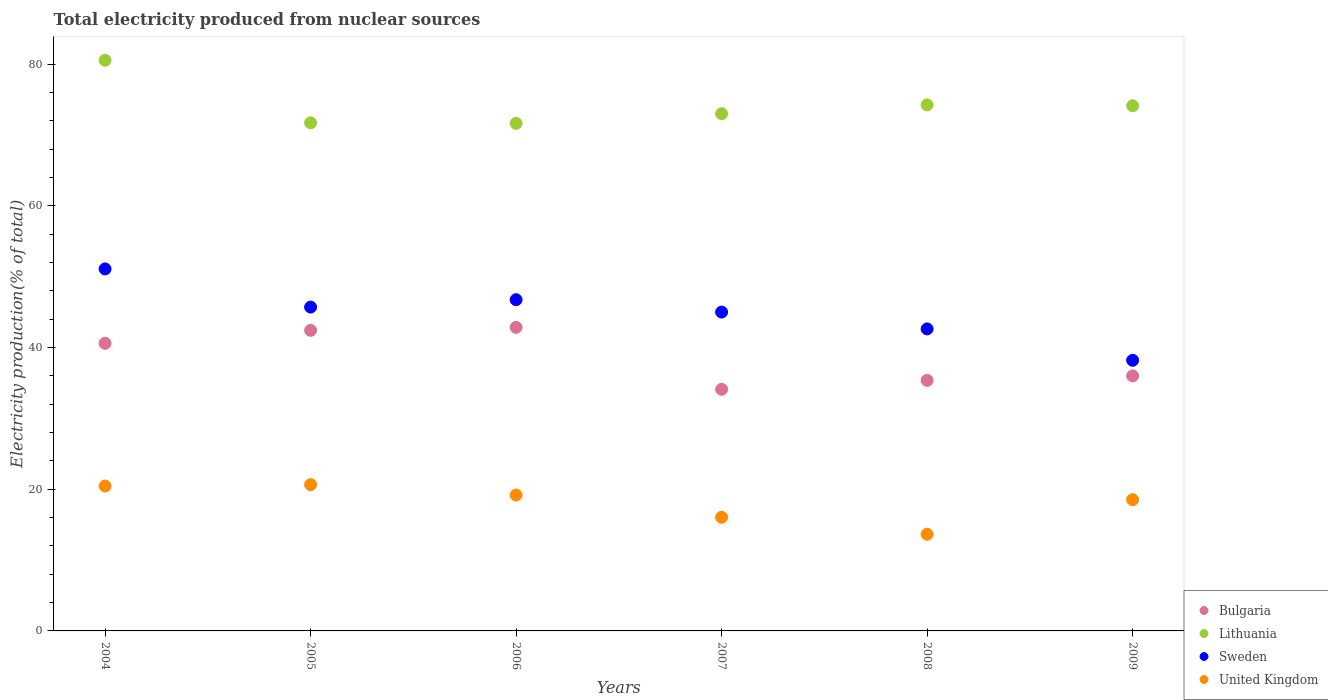How many different coloured dotlines are there?
Provide a short and direct response. 4. What is the total electricity produced in Sweden in 2004?
Give a very brief answer. 51.09. Across all years, what is the maximum total electricity produced in Sweden?
Ensure brevity in your answer.  51.09. Across all years, what is the minimum total electricity produced in United Kingdom?
Offer a very short reply. 13.64. What is the total total electricity produced in Bulgaria in the graph?
Offer a terse response. 231.31. What is the difference between the total electricity produced in Bulgaria in 2004 and that in 2006?
Keep it short and to the point. -2.25. What is the difference between the total electricity produced in United Kingdom in 2006 and the total electricity produced in Bulgaria in 2009?
Provide a short and direct response. -16.82. What is the average total electricity produced in Sweden per year?
Offer a very short reply. 44.89. In the year 2005, what is the difference between the total electricity produced in United Kingdom and total electricity produced in Sweden?
Offer a terse response. -25.06. What is the ratio of the total electricity produced in Lithuania in 2004 to that in 2008?
Your answer should be very brief. 1.08. What is the difference between the highest and the second highest total electricity produced in Lithuania?
Provide a short and direct response. 6.3. What is the difference between the highest and the lowest total electricity produced in Lithuania?
Keep it short and to the point. 8.9. In how many years, is the total electricity produced in Lithuania greater than the average total electricity produced in Lithuania taken over all years?
Your answer should be very brief. 2. Is it the case that in every year, the sum of the total electricity produced in Sweden and total electricity produced in Lithuania  is greater than the total electricity produced in United Kingdom?
Your answer should be compact. Yes. Does the total electricity produced in United Kingdom monotonically increase over the years?
Make the answer very short. No. Is the total electricity produced in Lithuania strictly less than the total electricity produced in Bulgaria over the years?
Make the answer very short. No. What is the difference between two consecutive major ticks on the Y-axis?
Provide a succinct answer. 20. Does the graph contain grids?
Keep it short and to the point. No. How are the legend labels stacked?
Ensure brevity in your answer.  Vertical. What is the title of the graph?
Offer a very short reply. Total electricity produced from nuclear sources. What is the label or title of the X-axis?
Your answer should be compact. Years. What is the label or title of the Y-axis?
Your response must be concise. Electricity production(% of total). What is the Electricity production(% of total) in Bulgaria in 2004?
Keep it short and to the point. 40.59. What is the Electricity production(% of total) of Lithuania in 2004?
Give a very brief answer. 80.54. What is the Electricity production(% of total) in Sweden in 2004?
Keep it short and to the point. 51.09. What is the Electricity production(% of total) of United Kingdom in 2004?
Offer a very short reply. 20.45. What is the Electricity production(% of total) of Bulgaria in 2005?
Give a very brief answer. 42.42. What is the Electricity production(% of total) of Lithuania in 2005?
Your response must be concise. 71.71. What is the Electricity production(% of total) of Sweden in 2005?
Your answer should be compact. 45.7. What is the Electricity production(% of total) of United Kingdom in 2005?
Offer a terse response. 20.64. What is the Electricity production(% of total) in Bulgaria in 2006?
Give a very brief answer. 42.84. What is the Electricity production(% of total) in Lithuania in 2006?
Offer a very short reply. 71.63. What is the Electricity production(% of total) in Sweden in 2006?
Provide a succinct answer. 46.74. What is the Electricity production(% of total) of United Kingdom in 2006?
Offer a very short reply. 19.18. What is the Electricity production(% of total) of Bulgaria in 2007?
Give a very brief answer. 34.1. What is the Electricity production(% of total) of Lithuania in 2007?
Ensure brevity in your answer.  73. What is the Electricity production(% of total) of Sweden in 2007?
Offer a very short reply. 45. What is the Electricity production(% of total) in United Kingdom in 2007?
Keep it short and to the point. 16.04. What is the Electricity production(% of total) of Bulgaria in 2008?
Offer a terse response. 35.36. What is the Electricity production(% of total) in Lithuania in 2008?
Offer a terse response. 74.24. What is the Electricity production(% of total) of Sweden in 2008?
Make the answer very short. 42.62. What is the Electricity production(% of total) of United Kingdom in 2008?
Give a very brief answer. 13.64. What is the Electricity production(% of total) in Bulgaria in 2009?
Ensure brevity in your answer.  36. What is the Electricity production(% of total) of Lithuania in 2009?
Give a very brief answer. 74.11. What is the Electricity production(% of total) in Sweden in 2009?
Ensure brevity in your answer.  38.19. What is the Electricity production(% of total) of United Kingdom in 2009?
Make the answer very short. 18.52. Across all years, what is the maximum Electricity production(% of total) of Bulgaria?
Your response must be concise. 42.84. Across all years, what is the maximum Electricity production(% of total) of Lithuania?
Offer a terse response. 80.54. Across all years, what is the maximum Electricity production(% of total) in Sweden?
Give a very brief answer. 51.09. Across all years, what is the maximum Electricity production(% of total) of United Kingdom?
Provide a succinct answer. 20.64. Across all years, what is the minimum Electricity production(% of total) in Bulgaria?
Make the answer very short. 34.1. Across all years, what is the minimum Electricity production(% of total) in Lithuania?
Keep it short and to the point. 71.63. Across all years, what is the minimum Electricity production(% of total) of Sweden?
Offer a very short reply. 38.19. Across all years, what is the minimum Electricity production(% of total) in United Kingdom?
Your answer should be very brief. 13.64. What is the total Electricity production(% of total) in Bulgaria in the graph?
Your answer should be very brief. 231.31. What is the total Electricity production(% of total) of Lithuania in the graph?
Keep it short and to the point. 445.23. What is the total Electricity production(% of total) of Sweden in the graph?
Offer a terse response. 269.35. What is the total Electricity production(% of total) in United Kingdom in the graph?
Make the answer very short. 108.46. What is the difference between the Electricity production(% of total) of Bulgaria in 2004 and that in 2005?
Offer a very short reply. -1.83. What is the difference between the Electricity production(% of total) in Lithuania in 2004 and that in 2005?
Ensure brevity in your answer.  8.83. What is the difference between the Electricity production(% of total) in Sweden in 2004 and that in 2005?
Your answer should be compact. 5.38. What is the difference between the Electricity production(% of total) of United Kingdom in 2004 and that in 2005?
Keep it short and to the point. -0.2. What is the difference between the Electricity production(% of total) of Bulgaria in 2004 and that in 2006?
Provide a short and direct response. -2.25. What is the difference between the Electricity production(% of total) of Lithuania in 2004 and that in 2006?
Provide a short and direct response. 8.9. What is the difference between the Electricity production(% of total) of Sweden in 2004 and that in 2006?
Keep it short and to the point. 4.34. What is the difference between the Electricity production(% of total) of United Kingdom in 2004 and that in 2006?
Provide a succinct answer. 1.27. What is the difference between the Electricity production(% of total) in Bulgaria in 2004 and that in 2007?
Ensure brevity in your answer.  6.49. What is the difference between the Electricity production(% of total) in Lithuania in 2004 and that in 2007?
Provide a succinct answer. 7.54. What is the difference between the Electricity production(% of total) in Sweden in 2004 and that in 2007?
Provide a succinct answer. 6.09. What is the difference between the Electricity production(% of total) in United Kingdom in 2004 and that in 2007?
Give a very brief answer. 4.41. What is the difference between the Electricity production(% of total) of Bulgaria in 2004 and that in 2008?
Keep it short and to the point. 5.23. What is the difference between the Electricity production(% of total) in Lithuania in 2004 and that in 2008?
Your response must be concise. 6.3. What is the difference between the Electricity production(% of total) in Sweden in 2004 and that in 2008?
Give a very brief answer. 8.46. What is the difference between the Electricity production(% of total) of United Kingdom in 2004 and that in 2008?
Your answer should be very brief. 6.8. What is the difference between the Electricity production(% of total) in Bulgaria in 2004 and that in 2009?
Your answer should be compact. 4.59. What is the difference between the Electricity production(% of total) of Lithuania in 2004 and that in 2009?
Give a very brief answer. 6.42. What is the difference between the Electricity production(% of total) in Sweden in 2004 and that in 2009?
Your answer should be very brief. 12.89. What is the difference between the Electricity production(% of total) of United Kingdom in 2004 and that in 2009?
Provide a short and direct response. 1.92. What is the difference between the Electricity production(% of total) of Bulgaria in 2005 and that in 2006?
Make the answer very short. -0.42. What is the difference between the Electricity production(% of total) of Lithuania in 2005 and that in 2006?
Your response must be concise. 0.08. What is the difference between the Electricity production(% of total) in Sweden in 2005 and that in 2006?
Your answer should be very brief. -1.04. What is the difference between the Electricity production(% of total) in United Kingdom in 2005 and that in 2006?
Your answer should be compact. 1.46. What is the difference between the Electricity production(% of total) of Bulgaria in 2005 and that in 2007?
Ensure brevity in your answer.  8.32. What is the difference between the Electricity production(% of total) in Lithuania in 2005 and that in 2007?
Your answer should be very brief. -1.29. What is the difference between the Electricity production(% of total) in Sweden in 2005 and that in 2007?
Provide a succinct answer. 0.7. What is the difference between the Electricity production(% of total) of United Kingdom in 2005 and that in 2007?
Keep it short and to the point. 4.6. What is the difference between the Electricity production(% of total) of Bulgaria in 2005 and that in 2008?
Your answer should be very brief. 7.06. What is the difference between the Electricity production(% of total) in Lithuania in 2005 and that in 2008?
Provide a succinct answer. -2.53. What is the difference between the Electricity production(% of total) of Sweden in 2005 and that in 2008?
Provide a short and direct response. 3.08. What is the difference between the Electricity production(% of total) in United Kingdom in 2005 and that in 2008?
Ensure brevity in your answer.  7. What is the difference between the Electricity production(% of total) in Bulgaria in 2005 and that in 2009?
Provide a short and direct response. 6.42. What is the difference between the Electricity production(% of total) in Lithuania in 2005 and that in 2009?
Ensure brevity in your answer.  -2.4. What is the difference between the Electricity production(% of total) of Sweden in 2005 and that in 2009?
Give a very brief answer. 7.51. What is the difference between the Electricity production(% of total) in United Kingdom in 2005 and that in 2009?
Provide a short and direct response. 2.12. What is the difference between the Electricity production(% of total) in Bulgaria in 2006 and that in 2007?
Provide a short and direct response. 8.74. What is the difference between the Electricity production(% of total) of Lithuania in 2006 and that in 2007?
Provide a succinct answer. -1.37. What is the difference between the Electricity production(% of total) in Sweden in 2006 and that in 2007?
Provide a short and direct response. 1.74. What is the difference between the Electricity production(% of total) of United Kingdom in 2006 and that in 2007?
Your answer should be very brief. 3.14. What is the difference between the Electricity production(% of total) in Bulgaria in 2006 and that in 2008?
Your response must be concise. 7.48. What is the difference between the Electricity production(% of total) of Lithuania in 2006 and that in 2008?
Make the answer very short. -2.61. What is the difference between the Electricity production(% of total) of Sweden in 2006 and that in 2008?
Keep it short and to the point. 4.12. What is the difference between the Electricity production(% of total) in United Kingdom in 2006 and that in 2008?
Keep it short and to the point. 5.54. What is the difference between the Electricity production(% of total) in Bulgaria in 2006 and that in 2009?
Provide a succinct answer. 6.84. What is the difference between the Electricity production(% of total) in Lithuania in 2006 and that in 2009?
Keep it short and to the point. -2.48. What is the difference between the Electricity production(% of total) of Sweden in 2006 and that in 2009?
Make the answer very short. 8.55. What is the difference between the Electricity production(% of total) of United Kingdom in 2006 and that in 2009?
Your response must be concise. 0.66. What is the difference between the Electricity production(% of total) of Bulgaria in 2007 and that in 2008?
Ensure brevity in your answer.  -1.26. What is the difference between the Electricity production(% of total) in Lithuania in 2007 and that in 2008?
Your answer should be very brief. -1.24. What is the difference between the Electricity production(% of total) in Sweden in 2007 and that in 2008?
Your response must be concise. 2.38. What is the difference between the Electricity production(% of total) of United Kingdom in 2007 and that in 2008?
Keep it short and to the point. 2.4. What is the difference between the Electricity production(% of total) of Bulgaria in 2007 and that in 2009?
Your response must be concise. -1.89. What is the difference between the Electricity production(% of total) of Lithuania in 2007 and that in 2009?
Give a very brief answer. -1.11. What is the difference between the Electricity production(% of total) in Sweden in 2007 and that in 2009?
Ensure brevity in your answer.  6.81. What is the difference between the Electricity production(% of total) in United Kingdom in 2007 and that in 2009?
Offer a very short reply. -2.48. What is the difference between the Electricity production(% of total) in Bulgaria in 2008 and that in 2009?
Ensure brevity in your answer.  -0.64. What is the difference between the Electricity production(% of total) in Lithuania in 2008 and that in 2009?
Provide a short and direct response. 0.13. What is the difference between the Electricity production(% of total) of Sweden in 2008 and that in 2009?
Keep it short and to the point. 4.43. What is the difference between the Electricity production(% of total) in United Kingdom in 2008 and that in 2009?
Provide a succinct answer. -4.88. What is the difference between the Electricity production(% of total) in Bulgaria in 2004 and the Electricity production(% of total) in Lithuania in 2005?
Provide a short and direct response. -31.12. What is the difference between the Electricity production(% of total) in Bulgaria in 2004 and the Electricity production(% of total) in Sweden in 2005?
Your answer should be very brief. -5.11. What is the difference between the Electricity production(% of total) of Bulgaria in 2004 and the Electricity production(% of total) of United Kingdom in 2005?
Your response must be concise. 19.95. What is the difference between the Electricity production(% of total) of Lithuania in 2004 and the Electricity production(% of total) of Sweden in 2005?
Offer a terse response. 34.83. What is the difference between the Electricity production(% of total) of Lithuania in 2004 and the Electricity production(% of total) of United Kingdom in 2005?
Offer a very short reply. 59.89. What is the difference between the Electricity production(% of total) of Sweden in 2004 and the Electricity production(% of total) of United Kingdom in 2005?
Ensure brevity in your answer.  30.45. What is the difference between the Electricity production(% of total) in Bulgaria in 2004 and the Electricity production(% of total) in Lithuania in 2006?
Keep it short and to the point. -31.04. What is the difference between the Electricity production(% of total) of Bulgaria in 2004 and the Electricity production(% of total) of Sweden in 2006?
Provide a short and direct response. -6.15. What is the difference between the Electricity production(% of total) in Bulgaria in 2004 and the Electricity production(% of total) in United Kingdom in 2006?
Your response must be concise. 21.41. What is the difference between the Electricity production(% of total) in Lithuania in 2004 and the Electricity production(% of total) in Sweden in 2006?
Ensure brevity in your answer.  33.79. What is the difference between the Electricity production(% of total) of Lithuania in 2004 and the Electricity production(% of total) of United Kingdom in 2006?
Your answer should be very brief. 61.36. What is the difference between the Electricity production(% of total) in Sweden in 2004 and the Electricity production(% of total) in United Kingdom in 2006?
Give a very brief answer. 31.91. What is the difference between the Electricity production(% of total) in Bulgaria in 2004 and the Electricity production(% of total) in Lithuania in 2007?
Provide a short and direct response. -32.41. What is the difference between the Electricity production(% of total) in Bulgaria in 2004 and the Electricity production(% of total) in Sweden in 2007?
Your answer should be compact. -4.41. What is the difference between the Electricity production(% of total) in Bulgaria in 2004 and the Electricity production(% of total) in United Kingdom in 2007?
Provide a short and direct response. 24.55. What is the difference between the Electricity production(% of total) in Lithuania in 2004 and the Electricity production(% of total) in Sweden in 2007?
Offer a very short reply. 35.54. What is the difference between the Electricity production(% of total) in Lithuania in 2004 and the Electricity production(% of total) in United Kingdom in 2007?
Offer a very short reply. 64.5. What is the difference between the Electricity production(% of total) in Sweden in 2004 and the Electricity production(% of total) in United Kingdom in 2007?
Keep it short and to the point. 35.05. What is the difference between the Electricity production(% of total) in Bulgaria in 2004 and the Electricity production(% of total) in Lithuania in 2008?
Provide a short and direct response. -33.65. What is the difference between the Electricity production(% of total) of Bulgaria in 2004 and the Electricity production(% of total) of Sweden in 2008?
Your response must be concise. -2.03. What is the difference between the Electricity production(% of total) of Bulgaria in 2004 and the Electricity production(% of total) of United Kingdom in 2008?
Give a very brief answer. 26.95. What is the difference between the Electricity production(% of total) in Lithuania in 2004 and the Electricity production(% of total) in Sweden in 2008?
Your answer should be compact. 37.91. What is the difference between the Electricity production(% of total) in Lithuania in 2004 and the Electricity production(% of total) in United Kingdom in 2008?
Give a very brief answer. 66.9. What is the difference between the Electricity production(% of total) of Sweden in 2004 and the Electricity production(% of total) of United Kingdom in 2008?
Make the answer very short. 37.45. What is the difference between the Electricity production(% of total) in Bulgaria in 2004 and the Electricity production(% of total) in Lithuania in 2009?
Offer a terse response. -33.52. What is the difference between the Electricity production(% of total) of Bulgaria in 2004 and the Electricity production(% of total) of Sweden in 2009?
Provide a succinct answer. 2.4. What is the difference between the Electricity production(% of total) of Bulgaria in 2004 and the Electricity production(% of total) of United Kingdom in 2009?
Your answer should be very brief. 22.07. What is the difference between the Electricity production(% of total) in Lithuania in 2004 and the Electricity production(% of total) in Sweden in 2009?
Give a very brief answer. 42.34. What is the difference between the Electricity production(% of total) of Lithuania in 2004 and the Electricity production(% of total) of United Kingdom in 2009?
Give a very brief answer. 62.01. What is the difference between the Electricity production(% of total) in Sweden in 2004 and the Electricity production(% of total) in United Kingdom in 2009?
Offer a very short reply. 32.57. What is the difference between the Electricity production(% of total) of Bulgaria in 2005 and the Electricity production(% of total) of Lithuania in 2006?
Provide a short and direct response. -29.21. What is the difference between the Electricity production(% of total) of Bulgaria in 2005 and the Electricity production(% of total) of Sweden in 2006?
Provide a succinct answer. -4.32. What is the difference between the Electricity production(% of total) of Bulgaria in 2005 and the Electricity production(% of total) of United Kingdom in 2006?
Your answer should be compact. 23.24. What is the difference between the Electricity production(% of total) in Lithuania in 2005 and the Electricity production(% of total) in Sweden in 2006?
Your answer should be very brief. 24.97. What is the difference between the Electricity production(% of total) of Lithuania in 2005 and the Electricity production(% of total) of United Kingdom in 2006?
Make the answer very short. 52.53. What is the difference between the Electricity production(% of total) in Sweden in 2005 and the Electricity production(% of total) in United Kingdom in 2006?
Keep it short and to the point. 26.52. What is the difference between the Electricity production(% of total) of Bulgaria in 2005 and the Electricity production(% of total) of Lithuania in 2007?
Keep it short and to the point. -30.58. What is the difference between the Electricity production(% of total) of Bulgaria in 2005 and the Electricity production(% of total) of Sweden in 2007?
Your response must be concise. -2.58. What is the difference between the Electricity production(% of total) in Bulgaria in 2005 and the Electricity production(% of total) in United Kingdom in 2007?
Ensure brevity in your answer.  26.38. What is the difference between the Electricity production(% of total) of Lithuania in 2005 and the Electricity production(% of total) of Sweden in 2007?
Make the answer very short. 26.71. What is the difference between the Electricity production(% of total) of Lithuania in 2005 and the Electricity production(% of total) of United Kingdom in 2007?
Your answer should be compact. 55.67. What is the difference between the Electricity production(% of total) of Sweden in 2005 and the Electricity production(% of total) of United Kingdom in 2007?
Give a very brief answer. 29.66. What is the difference between the Electricity production(% of total) of Bulgaria in 2005 and the Electricity production(% of total) of Lithuania in 2008?
Make the answer very short. -31.82. What is the difference between the Electricity production(% of total) in Bulgaria in 2005 and the Electricity production(% of total) in Sweden in 2008?
Make the answer very short. -0.2. What is the difference between the Electricity production(% of total) in Bulgaria in 2005 and the Electricity production(% of total) in United Kingdom in 2008?
Your answer should be very brief. 28.78. What is the difference between the Electricity production(% of total) of Lithuania in 2005 and the Electricity production(% of total) of Sweden in 2008?
Give a very brief answer. 29.09. What is the difference between the Electricity production(% of total) in Lithuania in 2005 and the Electricity production(% of total) in United Kingdom in 2008?
Keep it short and to the point. 58.07. What is the difference between the Electricity production(% of total) of Sweden in 2005 and the Electricity production(% of total) of United Kingdom in 2008?
Provide a short and direct response. 32.06. What is the difference between the Electricity production(% of total) in Bulgaria in 2005 and the Electricity production(% of total) in Lithuania in 2009?
Offer a terse response. -31.69. What is the difference between the Electricity production(% of total) of Bulgaria in 2005 and the Electricity production(% of total) of Sweden in 2009?
Your answer should be very brief. 4.23. What is the difference between the Electricity production(% of total) of Bulgaria in 2005 and the Electricity production(% of total) of United Kingdom in 2009?
Make the answer very short. 23.9. What is the difference between the Electricity production(% of total) in Lithuania in 2005 and the Electricity production(% of total) in Sweden in 2009?
Your response must be concise. 33.52. What is the difference between the Electricity production(% of total) of Lithuania in 2005 and the Electricity production(% of total) of United Kingdom in 2009?
Provide a succinct answer. 53.19. What is the difference between the Electricity production(% of total) of Sweden in 2005 and the Electricity production(% of total) of United Kingdom in 2009?
Your answer should be very brief. 27.18. What is the difference between the Electricity production(% of total) of Bulgaria in 2006 and the Electricity production(% of total) of Lithuania in 2007?
Give a very brief answer. -30.16. What is the difference between the Electricity production(% of total) in Bulgaria in 2006 and the Electricity production(% of total) in Sweden in 2007?
Offer a terse response. -2.16. What is the difference between the Electricity production(% of total) in Bulgaria in 2006 and the Electricity production(% of total) in United Kingdom in 2007?
Your response must be concise. 26.8. What is the difference between the Electricity production(% of total) of Lithuania in 2006 and the Electricity production(% of total) of Sweden in 2007?
Provide a short and direct response. 26.63. What is the difference between the Electricity production(% of total) of Lithuania in 2006 and the Electricity production(% of total) of United Kingdom in 2007?
Your response must be concise. 55.59. What is the difference between the Electricity production(% of total) in Sweden in 2006 and the Electricity production(% of total) in United Kingdom in 2007?
Provide a succinct answer. 30.7. What is the difference between the Electricity production(% of total) in Bulgaria in 2006 and the Electricity production(% of total) in Lithuania in 2008?
Your response must be concise. -31.4. What is the difference between the Electricity production(% of total) of Bulgaria in 2006 and the Electricity production(% of total) of Sweden in 2008?
Make the answer very short. 0.22. What is the difference between the Electricity production(% of total) of Bulgaria in 2006 and the Electricity production(% of total) of United Kingdom in 2008?
Make the answer very short. 29.2. What is the difference between the Electricity production(% of total) in Lithuania in 2006 and the Electricity production(% of total) in Sweden in 2008?
Provide a short and direct response. 29.01. What is the difference between the Electricity production(% of total) of Lithuania in 2006 and the Electricity production(% of total) of United Kingdom in 2008?
Keep it short and to the point. 57.99. What is the difference between the Electricity production(% of total) in Sweden in 2006 and the Electricity production(% of total) in United Kingdom in 2008?
Give a very brief answer. 33.1. What is the difference between the Electricity production(% of total) of Bulgaria in 2006 and the Electricity production(% of total) of Lithuania in 2009?
Offer a terse response. -31.27. What is the difference between the Electricity production(% of total) in Bulgaria in 2006 and the Electricity production(% of total) in Sweden in 2009?
Your answer should be compact. 4.65. What is the difference between the Electricity production(% of total) of Bulgaria in 2006 and the Electricity production(% of total) of United Kingdom in 2009?
Your answer should be compact. 24.32. What is the difference between the Electricity production(% of total) of Lithuania in 2006 and the Electricity production(% of total) of Sweden in 2009?
Ensure brevity in your answer.  33.44. What is the difference between the Electricity production(% of total) in Lithuania in 2006 and the Electricity production(% of total) in United Kingdom in 2009?
Give a very brief answer. 53.11. What is the difference between the Electricity production(% of total) in Sweden in 2006 and the Electricity production(% of total) in United Kingdom in 2009?
Offer a terse response. 28.22. What is the difference between the Electricity production(% of total) in Bulgaria in 2007 and the Electricity production(% of total) in Lithuania in 2008?
Offer a terse response. -40.14. What is the difference between the Electricity production(% of total) of Bulgaria in 2007 and the Electricity production(% of total) of Sweden in 2008?
Provide a succinct answer. -8.52. What is the difference between the Electricity production(% of total) of Bulgaria in 2007 and the Electricity production(% of total) of United Kingdom in 2008?
Provide a short and direct response. 20.46. What is the difference between the Electricity production(% of total) of Lithuania in 2007 and the Electricity production(% of total) of Sweden in 2008?
Your answer should be very brief. 30.38. What is the difference between the Electricity production(% of total) in Lithuania in 2007 and the Electricity production(% of total) in United Kingdom in 2008?
Make the answer very short. 59.36. What is the difference between the Electricity production(% of total) of Sweden in 2007 and the Electricity production(% of total) of United Kingdom in 2008?
Your answer should be compact. 31.36. What is the difference between the Electricity production(% of total) of Bulgaria in 2007 and the Electricity production(% of total) of Lithuania in 2009?
Give a very brief answer. -40.01. What is the difference between the Electricity production(% of total) of Bulgaria in 2007 and the Electricity production(% of total) of Sweden in 2009?
Give a very brief answer. -4.09. What is the difference between the Electricity production(% of total) in Bulgaria in 2007 and the Electricity production(% of total) in United Kingdom in 2009?
Your answer should be very brief. 15.58. What is the difference between the Electricity production(% of total) of Lithuania in 2007 and the Electricity production(% of total) of Sweden in 2009?
Give a very brief answer. 34.81. What is the difference between the Electricity production(% of total) of Lithuania in 2007 and the Electricity production(% of total) of United Kingdom in 2009?
Your response must be concise. 54.48. What is the difference between the Electricity production(% of total) in Sweden in 2007 and the Electricity production(% of total) in United Kingdom in 2009?
Your answer should be very brief. 26.48. What is the difference between the Electricity production(% of total) of Bulgaria in 2008 and the Electricity production(% of total) of Lithuania in 2009?
Your answer should be compact. -38.75. What is the difference between the Electricity production(% of total) in Bulgaria in 2008 and the Electricity production(% of total) in Sweden in 2009?
Provide a succinct answer. -2.83. What is the difference between the Electricity production(% of total) of Bulgaria in 2008 and the Electricity production(% of total) of United Kingdom in 2009?
Give a very brief answer. 16.84. What is the difference between the Electricity production(% of total) in Lithuania in 2008 and the Electricity production(% of total) in Sweden in 2009?
Ensure brevity in your answer.  36.05. What is the difference between the Electricity production(% of total) in Lithuania in 2008 and the Electricity production(% of total) in United Kingdom in 2009?
Ensure brevity in your answer.  55.72. What is the difference between the Electricity production(% of total) in Sweden in 2008 and the Electricity production(% of total) in United Kingdom in 2009?
Your response must be concise. 24.1. What is the average Electricity production(% of total) in Bulgaria per year?
Give a very brief answer. 38.55. What is the average Electricity production(% of total) of Lithuania per year?
Keep it short and to the point. 74.2. What is the average Electricity production(% of total) in Sweden per year?
Provide a succinct answer. 44.89. What is the average Electricity production(% of total) in United Kingdom per year?
Provide a short and direct response. 18.08. In the year 2004, what is the difference between the Electricity production(% of total) of Bulgaria and Electricity production(% of total) of Lithuania?
Offer a terse response. -39.95. In the year 2004, what is the difference between the Electricity production(% of total) in Bulgaria and Electricity production(% of total) in Sweden?
Keep it short and to the point. -10.5. In the year 2004, what is the difference between the Electricity production(% of total) of Bulgaria and Electricity production(% of total) of United Kingdom?
Make the answer very short. 20.15. In the year 2004, what is the difference between the Electricity production(% of total) in Lithuania and Electricity production(% of total) in Sweden?
Offer a very short reply. 29.45. In the year 2004, what is the difference between the Electricity production(% of total) in Lithuania and Electricity production(% of total) in United Kingdom?
Your answer should be very brief. 60.09. In the year 2004, what is the difference between the Electricity production(% of total) in Sweden and Electricity production(% of total) in United Kingdom?
Offer a very short reply. 30.64. In the year 2005, what is the difference between the Electricity production(% of total) of Bulgaria and Electricity production(% of total) of Lithuania?
Your answer should be compact. -29.29. In the year 2005, what is the difference between the Electricity production(% of total) in Bulgaria and Electricity production(% of total) in Sweden?
Offer a very short reply. -3.28. In the year 2005, what is the difference between the Electricity production(% of total) of Bulgaria and Electricity production(% of total) of United Kingdom?
Ensure brevity in your answer.  21.78. In the year 2005, what is the difference between the Electricity production(% of total) in Lithuania and Electricity production(% of total) in Sweden?
Offer a very short reply. 26.01. In the year 2005, what is the difference between the Electricity production(% of total) of Lithuania and Electricity production(% of total) of United Kingdom?
Provide a short and direct response. 51.07. In the year 2005, what is the difference between the Electricity production(% of total) in Sweden and Electricity production(% of total) in United Kingdom?
Offer a very short reply. 25.06. In the year 2006, what is the difference between the Electricity production(% of total) in Bulgaria and Electricity production(% of total) in Lithuania?
Ensure brevity in your answer.  -28.79. In the year 2006, what is the difference between the Electricity production(% of total) in Bulgaria and Electricity production(% of total) in Sweden?
Your response must be concise. -3.9. In the year 2006, what is the difference between the Electricity production(% of total) of Bulgaria and Electricity production(% of total) of United Kingdom?
Your response must be concise. 23.66. In the year 2006, what is the difference between the Electricity production(% of total) of Lithuania and Electricity production(% of total) of Sweden?
Provide a succinct answer. 24.89. In the year 2006, what is the difference between the Electricity production(% of total) of Lithuania and Electricity production(% of total) of United Kingdom?
Make the answer very short. 52.45. In the year 2006, what is the difference between the Electricity production(% of total) in Sweden and Electricity production(% of total) in United Kingdom?
Give a very brief answer. 27.57. In the year 2007, what is the difference between the Electricity production(% of total) of Bulgaria and Electricity production(% of total) of Lithuania?
Your answer should be compact. -38.9. In the year 2007, what is the difference between the Electricity production(% of total) of Bulgaria and Electricity production(% of total) of Sweden?
Ensure brevity in your answer.  -10.9. In the year 2007, what is the difference between the Electricity production(% of total) in Bulgaria and Electricity production(% of total) in United Kingdom?
Ensure brevity in your answer.  18.06. In the year 2007, what is the difference between the Electricity production(% of total) in Lithuania and Electricity production(% of total) in Sweden?
Offer a very short reply. 28. In the year 2007, what is the difference between the Electricity production(% of total) of Lithuania and Electricity production(% of total) of United Kingdom?
Your answer should be very brief. 56.96. In the year 2007, what is the difference between the Electricity production(% of total) of Sweden and Electricity production(% of total) of United Kingdom?
Your answer should be compact. 28.96. In the year 2008, what is the difference between the Electricity production(% of total) of Bulgaria and Electricity production(% of total) of Lithuania?
Offer a terse response. -38.88. In the year 2008, what is the difference between the Electricity production(% of total) of Bulgaria and Electricity production(% of total) of Sweden?
Provide a succinct answer. -7.26. In the year 2008, what is the difference between the Electricity production(% of total) of Bulgaria and Electricity production(% of total) of United Kingdom?
Make the answer very short. 21.72. In the year 2008, what is the difference between the Electricity production(% of total) in Lithuania and Electricity production(% of total) in Sweden?
Offer a terse response. 31.62. In the year 2008, what is the difference between the Electricity production(% of total) in Lithuania and Electricity production(% of total) in United Kingdom?
Offer a very short reply. 60.6. In the year 2008, what is the difference between the Electricity production(% of total) in Sweden and Electricity production(% of total) in United Kingdom?
Offer a terse response. 28.98. In the year 2009, what is the difference between the Electricity production(% of total) of Bulgaria and Electricity production(% of total) of Lithuania?
Your answer should be very brief. -38.11. In the year 2009, what is the difference between the Electricity production(% of total) in Bulgaria and Electricity production(% of total) in Sweden?
Give a very brief answer. -2.2. In the year 2009, what is the difference between the Electricity production(% of total) in Bulgaria and Electricity production(% of total) in United Kingdom?
Your answer should be very brief. 17.48. In the year 2009, what is the difference between the Electricity production(% of total) of Lithuania and Electricity production(% of total) of Sweden?
Your answer should be compact. 35.92. In the year 2009, what is the difference between the Electricity production(% of total) in Lithuania and Electricity production(% of total) in United Kingdom?
Provide a short and direct response. 55.59. In the year 2009, what is the difference between the Electricity production(% of total) of Sweden and Electricity production(% of total) of United Kingdom?
Your answer should be very brief. 19.67. What is the ratio of the Electricity production(% of total) in Bulgaria in 2004 to that in 2005?
Your answer should be compact. 0.96. What is the ratio of the Electricity production(% of total) of Lithuania in 2004 to that in 2005?
Offer a terse response. 1.12. What is the ratio of the Electricity production(% of total) in Sweden in 2004 to that in 2005?
Give a very brief answer. 1.12. What is the ratio of the Electricity production(% of total) of Bulgaria in 2004 to that in 2006?
Provide a succinct answer. 0.95. What is the ratio of the Electricity production(% of total) of Lithuania in 2004 to that in 2006?
Your answer should be very brief. 1.12. What is the ratio of the Electricity production(% of total) in Sweden in 2004 to that in 2006?
Make the answer very short. 1.09. What is the ratio of the Electricity production(% of total) in United Kingdom in 2004 to that in 2006?
Your answer should be very brief. 1.07. What is the ratio of the Electricity production(% of total) of Bulgaria in 2004 to that in 2007?
Offer a terse response. 1.19. What is the ratio of the Electricity production(% of total) in Lithuania in 2004 to that in 2007?
Offer a terse response. 1.1. What is the ratio of the Electricity production(% of total) of Sweden in 2004 to that in 2007?
Your response must be concise. 1.14. What is the ratio of the Electricity production(% of total) of United Kingdom in 2004 to that in 2007?
Provide a short and direct response. 1.27. What is the ratio of the Electricity production(% of total) of Bulgaria in 2004 to that in 2008?
Provide a succinct answer. 1.15. What is the ratio of the Electricity production(% of total) of Lithuania in 2004 to that in 2008?
Ensure brevity in your answer.  1.08. What is the ratio of the Electricity production(% of total) in Sweden in 2004 to that in 2008?
Make the answer very short. 1.2. What is the ratio of the Electricity production(% of total) in United Kingdom in 2004 to that in 2008?
Your answer should be compact. 1.5. What is the ratio of the Electricity production(% of total) of Bulgaria in 2004 to that in 2009?
Ensure brevity in your answer.  1.13. What is the ratio of the Electricity production(% of total) of Lithuania in 2004 to that in 2009?
Provide a succinct answer. 1.09. What is the ratio of the Electricity production(% of total) of Sweden in 2004 to that in 2009?
Ensure brevity in your answer.  1.34. What is the ratio of the Electricity production(% of total) in United Kingdom in 2004 to that in 2009?
Your response must be concise. 1.1. What is the ratio of the Electricity production(% of total) in Bulgaria in 2005 to that in 2006?
Ensure brevity in your answer.  0.99. What is the ratio of the Electricity production(% of total) in Lithuania in 2005 to that in 2006?
Your answer should be compact. 1. What is the ratio of the Electricity production(% of total) of Sweden in 2005 to that in 2006?
Your answer should be very brief. 0.98. What is the ratio of the Electricity production(% of total) in United Kingdom in 2005 to that in 2006?
Your answer should be very brief. 1.08. What is the ratio of the Electricity production(% of total) in Bulgaria in 2005 to that in 2007?
Ensure brevity in your answer.  1.24. What is the ratio of the Electricity production(% of total) in Lithuania in 2005 to that in 2007?
Your answer should be very brief. 0.98. What is the ratio of the Electricity production(% of total) of Sweden in 2005 to that in 2007?
Give a very brief answer. 1.02. What is the ratio of the Electricity production(% of total) in United Kingdom in 2005 to that in 2007?
Your answer should be compact. 1.29. What is the ratio of the Electricity production(% of total) of Bulgaria in 2005 to that in 2008?
Make the answer very short. 1.2. What is the ratio of the Electricity production(% of total) of Lithuania in 2005 to that in 2008?
Offer a terse response. 0.97. What is the ratio of the Electricity production(% of total) of Sweden in 2005 to that in 2008?
Offer a terse response. 1.07. What is the ratio of the Electricity production(% of total) in United Kingdom in 2005 to that in 2008?
Your answer should be compact. 1.51. What is the ratio of the Electricity production(% of total) in Bulgaria in 2005 to that in 2009?
Your answer should be compact. 1.18. What is the ratio of the Electricity production(% of total) in Lithuania in 2005 to that in 2009?
Keep it short and to the point. 0.97. What is the ratio of the Electricity production(% of total) in Sweden in 2005 to that in 2009?
Your answer should be compact. 1.2. What is the ratio of the Electricity production(% of total) of United Kingdom in 2005 to that in 2009?
Provide a succinct answer. 1.11. What is the ratio of the Electricity production(% of total) in Bulgaria in 2006 to that in 2007?
Offer a terse response. 1.26. What is the ratio of the Electricity production(% of total) in Lithuania in 2006 to that in 2007?
Make the answer very short. 0.98. What is the ratio of the Electricity production(% of total) in Sweden in 2006 to that in 2007?
Ensure brevity in your answer.  1.04. What is the ratio of the Electricity production(% of total) of United Kingdom in 2006 to that in 2007?
Make the answer very short. 1.2. What is the ratio of the Electricity production(% of total) in Bulgaria in 2006 to that in 2008?
Ensure brevity in your answer.  1.21. What is the ratio of the Electricity production(% of total) in Lithuania in 2006 to that in 2008?
Offer a very short reply. 0.96. What is the ratio of the Electricity production(% of total) of Sweden in 2006 to that in 2008?
Ensure brevity in your answer.  1.1. What is the ratio of the Electricity production(% of total) in United Kingdom in 2006 to that in 2008?
Make the answer very short. 1.41. What is the ratio of the Electricity production(% of total) of Bulgaria in 2006 to that in 2009?
Offer a terse response. 1.19. What is the ratio of the Electricity production(% of total) of Lithuania in 2006 to that in 2009?
Provide a short and direct response. 0.97. What is the ratio of the Electricity production(% of total) in Sweden in 2006 to that in 2009?
Ensure brevity in your answer.  1.22. What is the ratio of the Electricity production(% of total) of United Kingdom in 2006 to that in 2009?
Keep it short and to the point. 1.04. What is the ratio of the Electricity production(% of total) in Bulgaria in 2007 to that in 2008?
Offer a very short reply. 0.96. What is the ratio of the Electricity production(% of total) in Lithuania in 2007 to that in 2008?
Your answer should be very brief. 0.98. What is the ratio of the Electricity production(% of total) in Sweden in 2007 to that in 2008?
Give a very brief answer. 1.06. What is the ratio of the Electricity production(% of total) of United Kingdom in 2007 to that in 2008?
Give a very brief answer. 1.18. What is the ratio of the Electricity production(% of total) in Bulgaria in 2007 to that in 2009?
Your response must be concise. 0.95. What is the ratio of the Electricity production(% of total) in Sweden in 2007 to that in 2009?
Your response must be concise. 1.18. What is the ratio of the Electricity production(% of total) of United Kingdom in 2007 to that in 2009?
Keep it short and to the point. 0.87. What is the ratio of the Electricity production(% of total) of Bulgaria in 2008 to that in 2009?
Keep it short and to the point. 0.98. What is the ratio of the Electricity production(% of total) of Sweden in 2008 to that in 2009?
Ensure brevity in your answer.  1.12. What is the ratio of the Electricity production(% of total) in United Kingdom in 2008 to that in 2009?
Your answer should be very brief. 0.74. What is the difference between the highest and the second highest Electricity production(% of total) in Bulgaria?
Make the answer very short. 0.42. What is the difference between the highest and the second highest Electricity production(% of total) in Lithuania?
Ensure brevity in your answer.  6.3. What is the difference between the highest and the second highest Electricity production(% of total) of Sweden?
Your response must be concise. 4.34. What is the difference between the highest and the second highest Electricity production(% of total) in United Kingdom?
Give a very brief answer. 0.2. What is the difference between the highest and the lowest Electricity production(% of total) of Bulgaria?
Ensure brevity in your answer.  8.74. What is the difference between the highest and the lowest Electricity production(% of total) in Lithuania?
Offer a terse response. 8.9. What is the difference between the highest and the lowest Electricity production(% of total) in Sweden?
Provide a succinct answer. 12.89. What is the difference between the highest and the lowest Electricity production(% of total) in United Kingdom?
Make the answer very short. 7. 